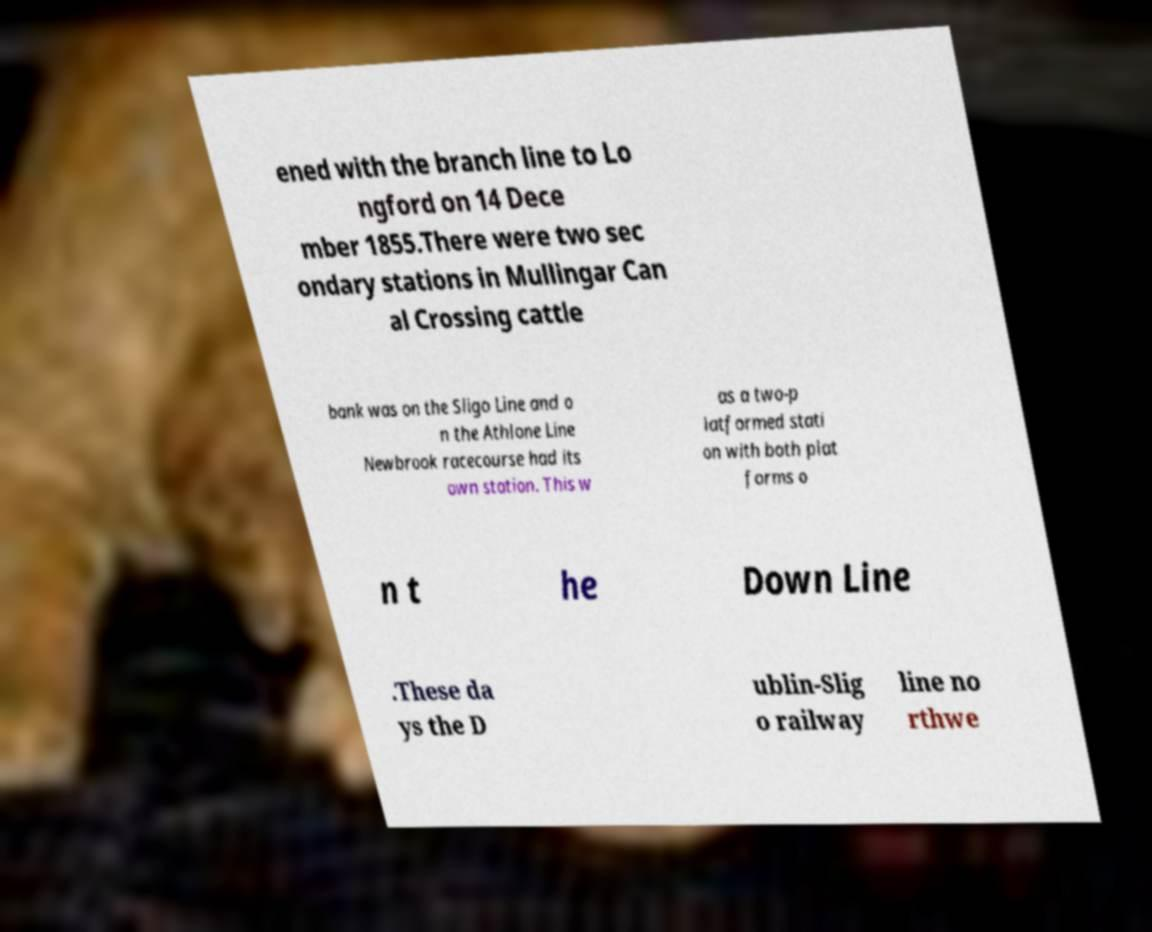Please identify and transcribe the text found in this image. ened with the branch line to Lo ngford on 14 Dece mber 1855.There were two sec ondary stations in Mullingar Can al Crossing cattle bank was on the Sligo Line and o n the Athlone Line Newbrook racecourse had its own station. This w as a two-p latformed stati on with both plat forms o n t he Down Line .These da ys the D ublin-Slig o railway line no rthwe 